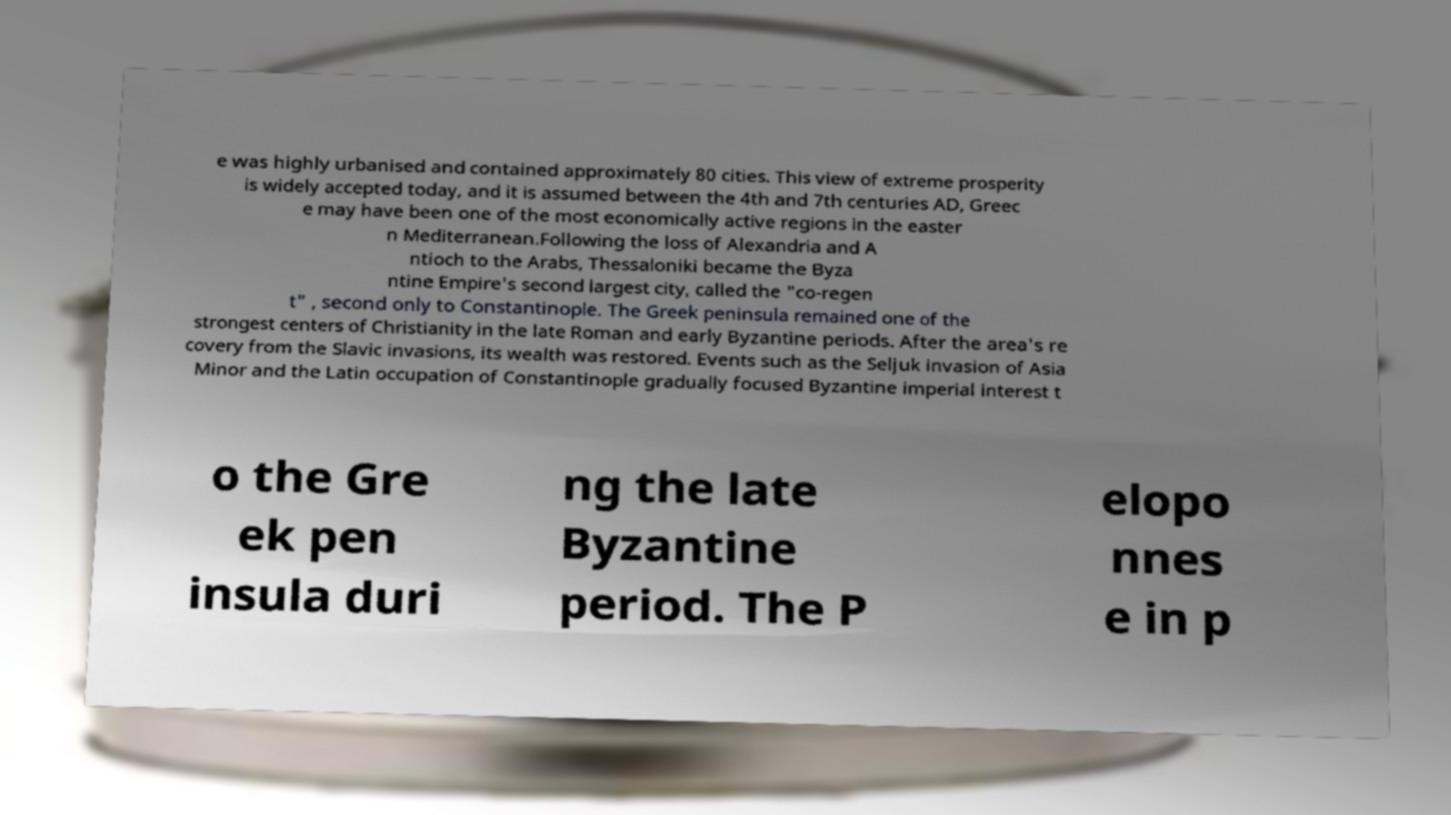What messages or text are displayed in this image? I need them in a readable, typed format. e was highly urbanised and contained approximately 80 cities. This view of extreme prosperity is widely accepted today, and it is assumed between the 4th and 7th centuries AD, Greec e may have been one of the most economically active regions in the easter n Mediterranean.Following the loss of Alexandria and A ntioch to the Arabs, Thessaloniki became the Byza ntine Empire's second largest city, called the "co-regen t" , second only to Constantinople. The Greek peninsula remained one of the strongest centers of Christianity in the late Roman and early Byzantine periods. After the area's re covery from the Slavic invasions, its wealth was restored. Events such as the Seljuk invasion of Asia Minor and the Latin occupation of Constantinople gradually focused Byzantine imperial interest t o the Gre ek pen insula duri ng the late Byzantine period. The P elopo nnes e in p 